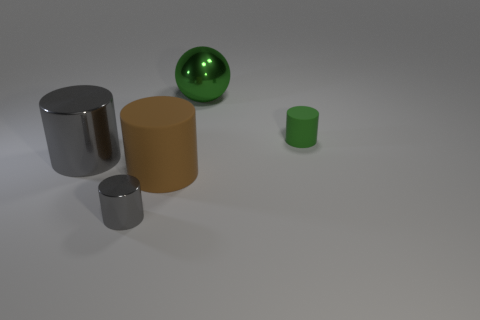There is a small cylinder that is the same color as the big sphere; what is it made of?
Your answer should be compact. Rubber. What number of big green spheres are there?
Your response must be concise. 1. Are there any large green objects that have the same material as the small green cylinder?
Ensure brevity in your answer.  No. There is another metal cylinder that is the same color as the tiny metal cylinder; what size is it?
Provide a short and direct response. Large. There is a green object in front of the sphere; does it have the same size as the gray object that is in front of the large brown matte object?
Ensure brevity in your answer.  Yes. How big is the gray object that is left of the small shiny cylinder?
Provide a succinct answer. Large. Is there a big metallic object that has the same color as the big rubber object?
Give a very brief answer. No. There is a tiny cylinder to the left of the large shiny ball; are there any small gray cylinders that are in front of it?
Make the answer very short. No. Do the metallic ball and the gray cylinder behind the large brown thing have the same size?
Provide a succinct answer. Yes. There is a big object behind the gray shiny object that is behind the small gray shiny cylinder; is there a big gray shiny thing that is behind it?
Your answer should be very brief. No. 